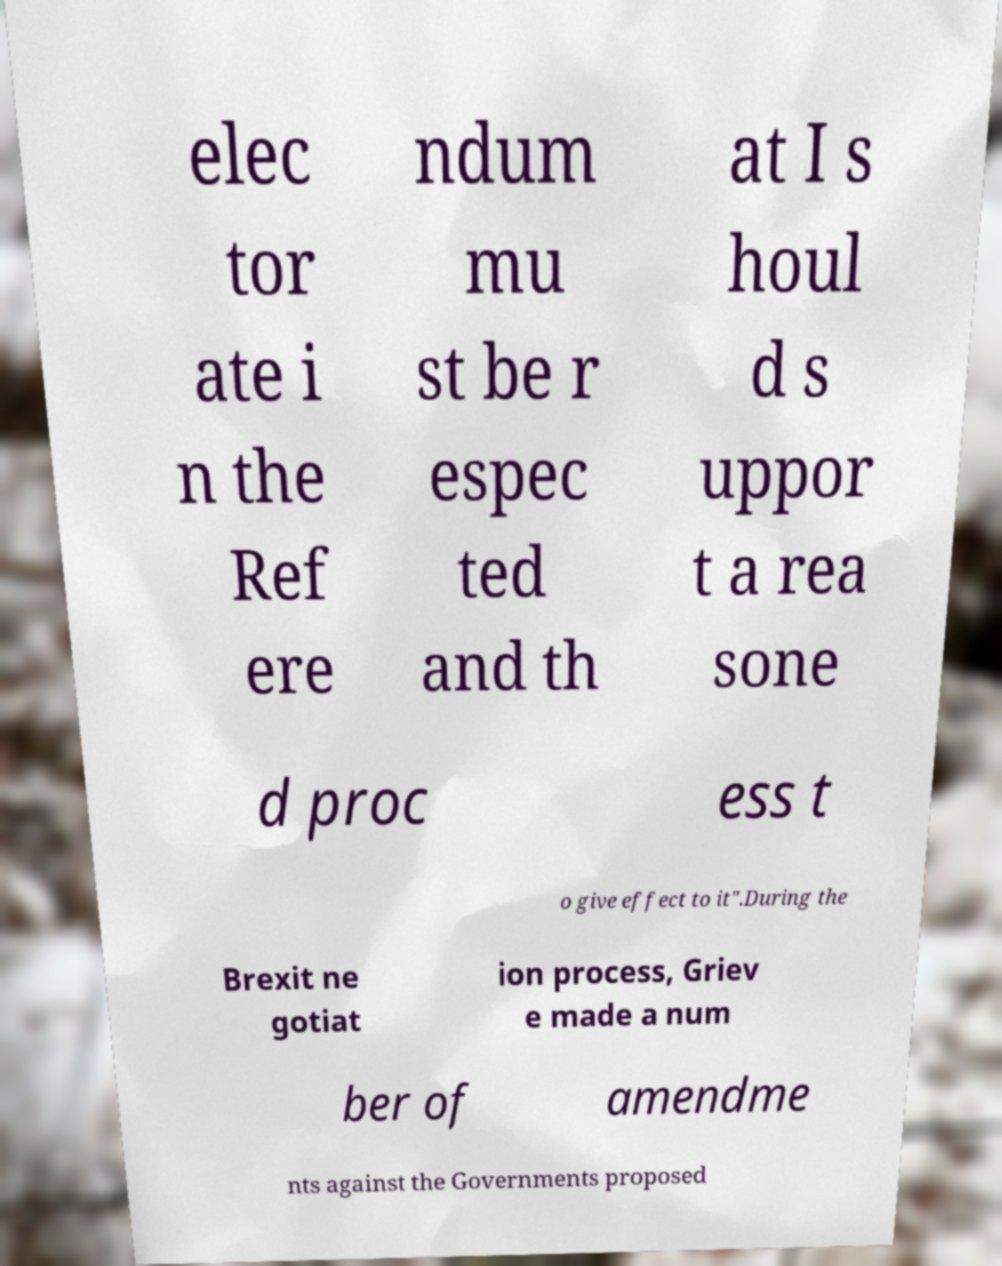Could you extract and type out the text from this image? elec tor ate i n the Ref ere ndum mu st be r espec ted and th at I s houl d s uppor t a rea sone d proc ess t o give effect to it".During the Brexit ne gotiat ion process, Griev e made a num ber of amendme nts against the Governments proposed 